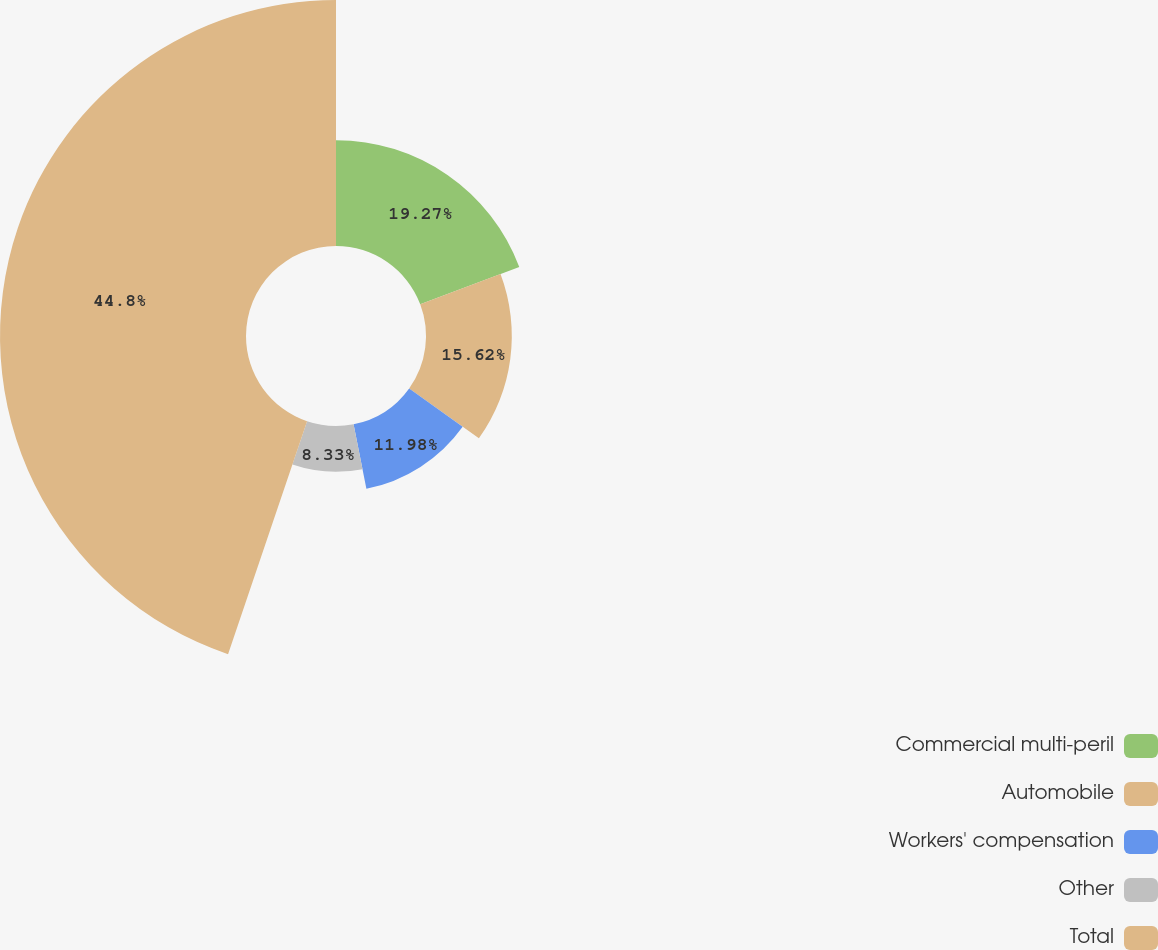Convert chart to OTSL. <chart><loc_0><loc_0><loc_500><loc_500><pie_chart><fcel>Commercial multi-peril<fcel>Automobile<fcel>Workers' compensation<fcel>Other<fcel>Total<nl><fcel>19.27%<fcel>15.62%<fcel>11.98%<fcel>8.33%<fcel>44.79%<nl></chart> 